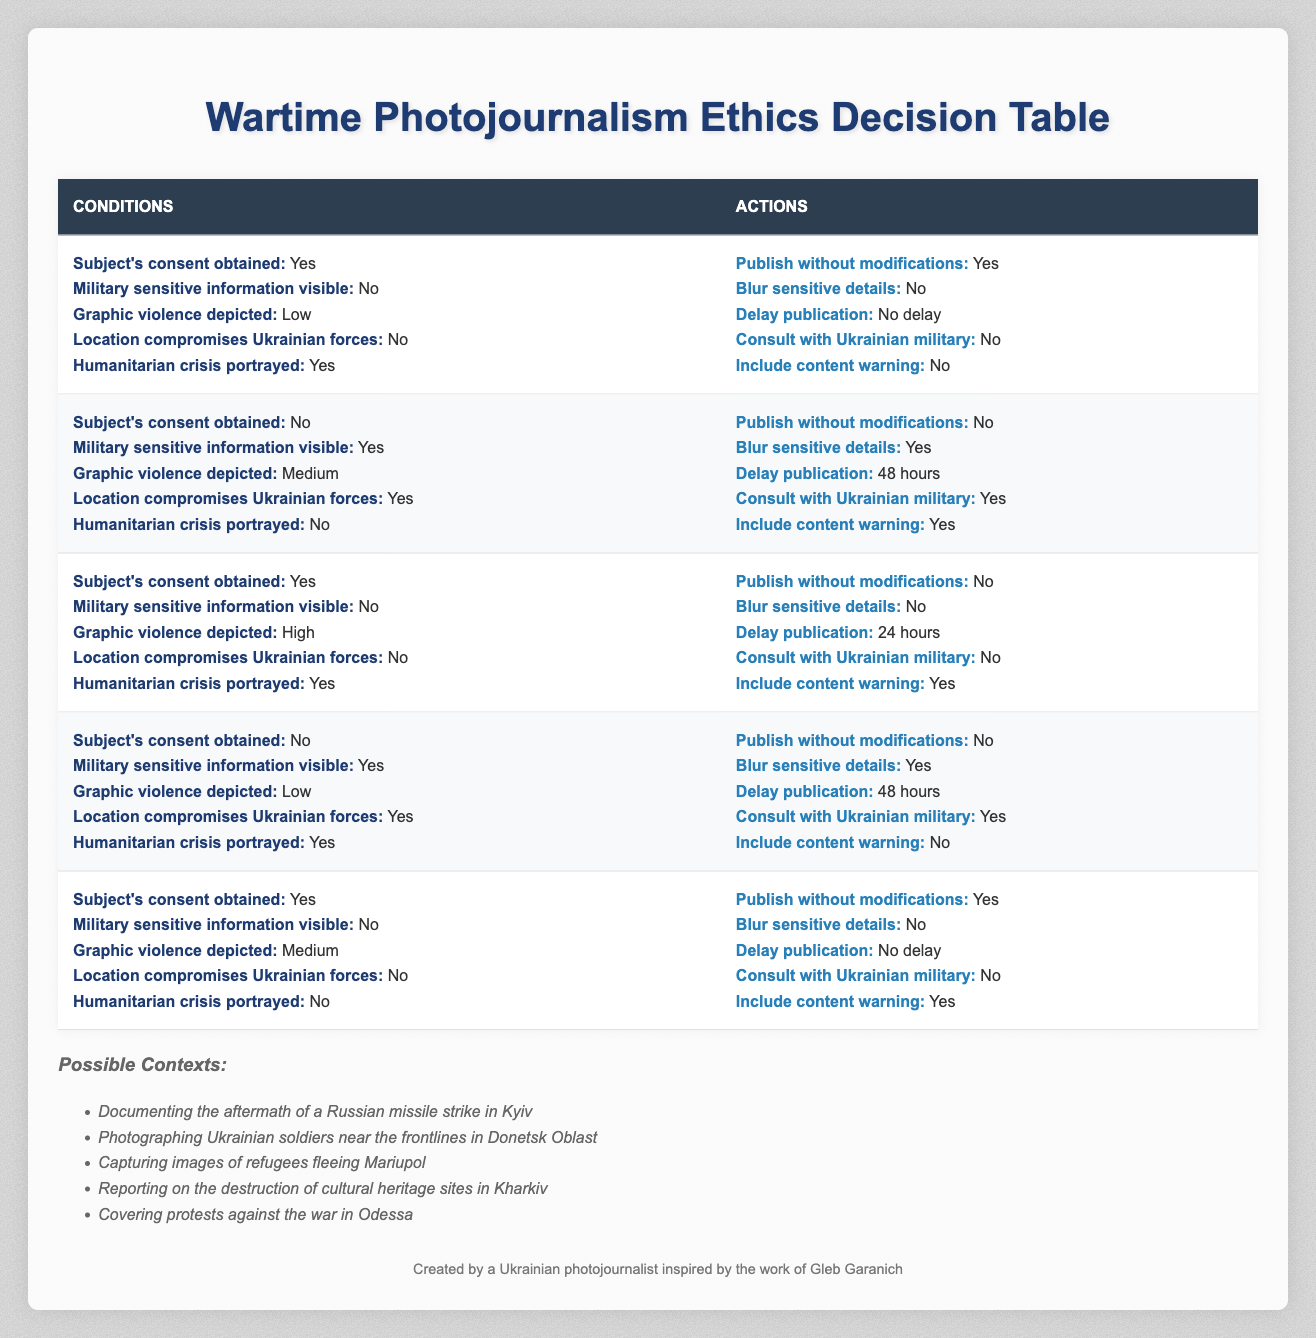What action is taken if the subject's consent is obtained, military sensitive information is not visible, graphic violence is low, location does not compromise forces, and humanitarian crisis is portrayed? According to the first rule in the table, if the conditions of subject's consent being obtained, military sensitive information not being visible, graphic violence depicted as low, location not compromising forces, and a humanitarian crisis being portrayed are met, the actions mandated are to publish without modifications, not blur sensitive details, delay publication with no delay, not consult with the military, and not include a content warning.
Answer: Publish without modifications, do not blur sensitive details, no delay, do not consult, do not include content warning Is there a scenario where military sensitive information is visible and the subject's consent is obtained? Looking through the table, it is apparent that if subject's consent is obtained, military sensitive information cannot be visible as per the existing rules. Thus, no such scenarios are present in the table.
Answer: No In how many scenarios is graphic violence depicted as high? A scan of the table reveals only one scenario where graphic violence is depicted as high, specifically the third rule. Thus, the count of scenarios where graphic violence is high is one.
Answer: One What is the required action when military sensitive information is visible, and the location compromises Ukrainian forces? Referring to the fourth rule of the table, when military sensitive information is visible and the location compromises Ukrainian forces, the actions taken include not publishing without modifications, blurring sensitive details, delaying publication for 48 hours, consulting the military, and not including a content warning.
Answer: Do not publish, blur details, delay 48 hours, consult military, do not include warning Does the table indicate that consent is not needed when a humanitarian crisis is portrayed? Carefully reviewing the table illustrates that there are instances where humanitarian crises are portrayed without the need for consent, specifically in rules two and four. However, this is context-dependent and does not universally apply.
Answer: No, consent is required What is the common action taken across all scenarios depicted in the table if military sensitive information is not visible? Analyzing the scenarios, when military sensitive information is not visible, the general trend shows that there are common actions including options for publishing without modifications or not, depending on other factors, thus there isn't a singular common action.
Answer: No common action identified 